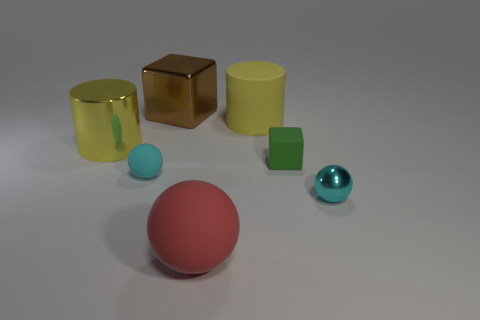Add 2 brown metal things. How many objects exist? 9 Subtract all cylinders. How many objects are left? 5 Add 5 large brown objects. How many large brown objects exist? 6 Subtract 0 gray balls. How many objects are left? 7 Subtract all large yellow metal things. Subtract all cyan matte spheres. How many objects are left? 5 Add 5 small metallic things. How many small metallic things are left? 6 